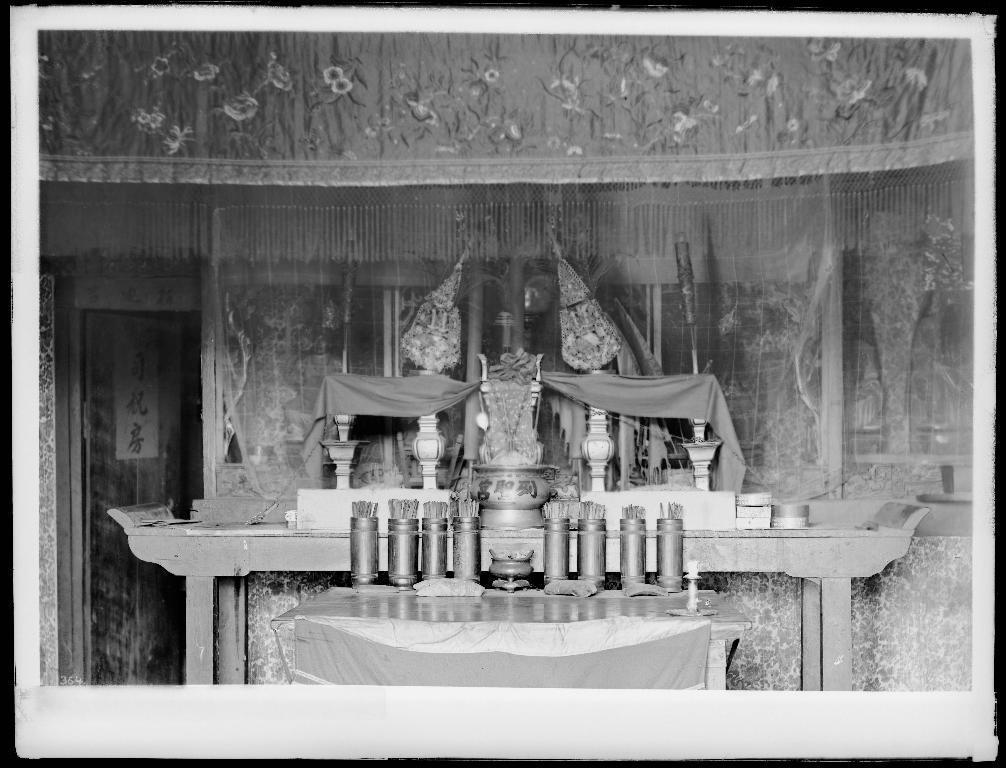Describe this image in one or two sentences. In this image I can see the black and white picture. I can see a table on which I can see few objects. In the background I can see the building, a cloth, the door and few words written on the door. 